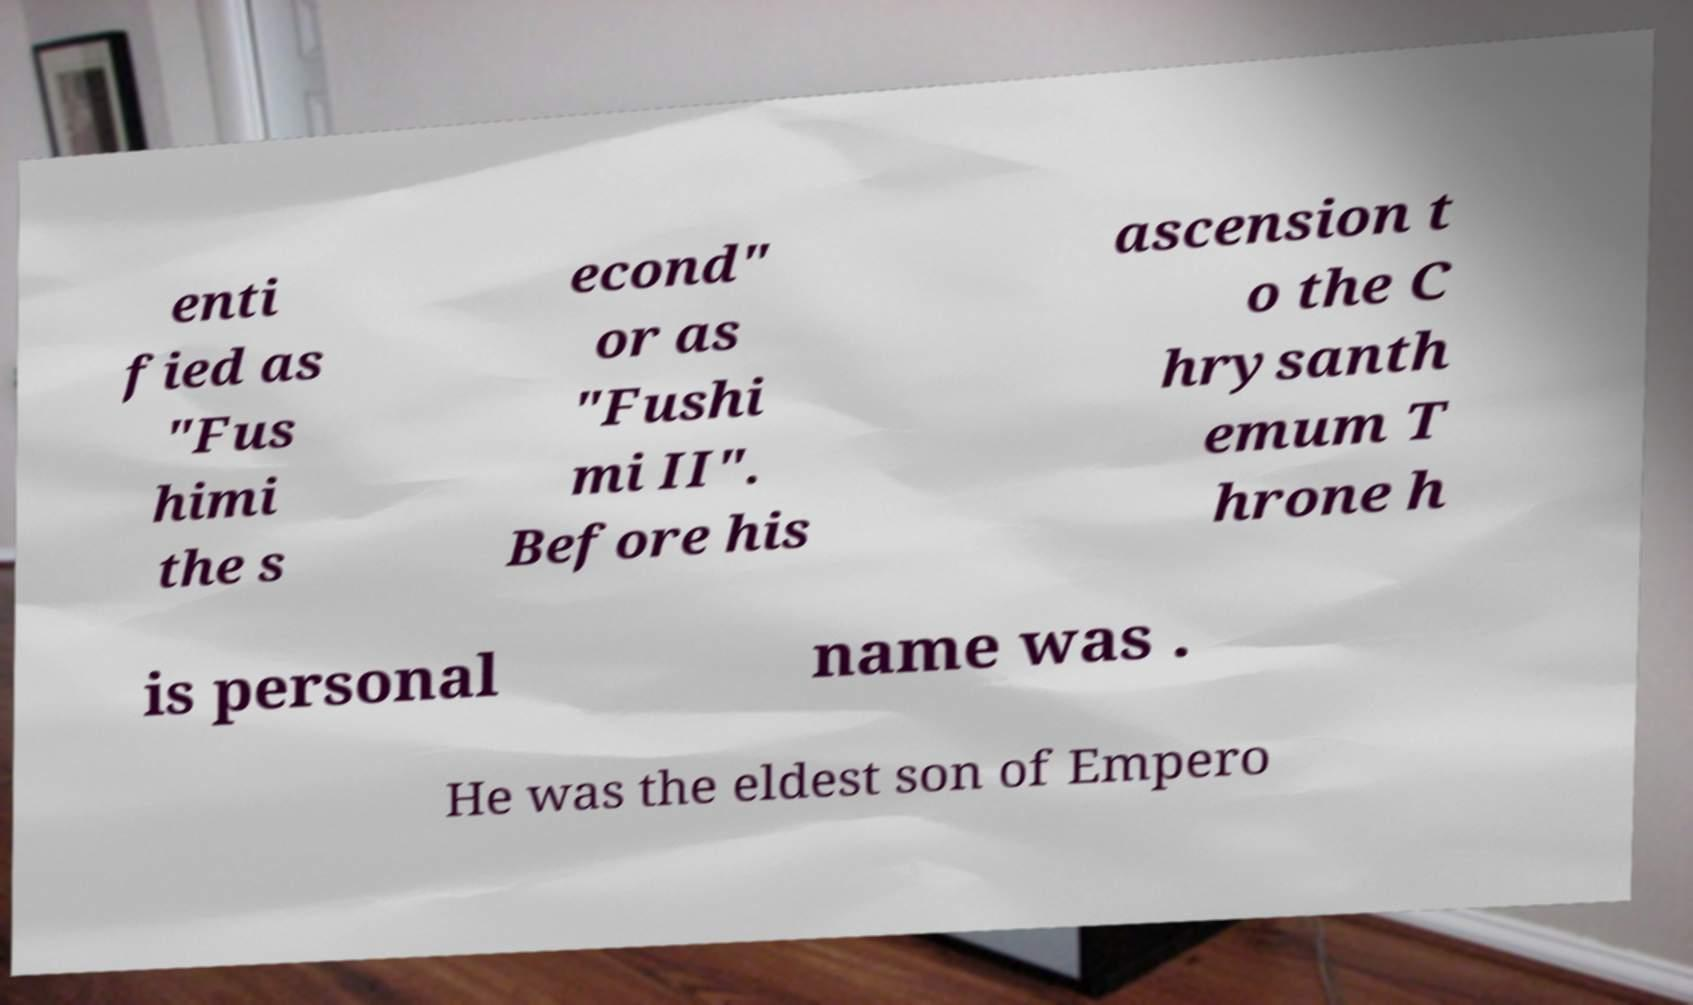Could you assist in decoding the text presented in this image and type it out clearly? enti fied as "Fus himi the s econd" or as "Fushi mi II". Before his ascension t o the C hrysanth emum T hrone h is personal name was . He was the eldest son of Empero 